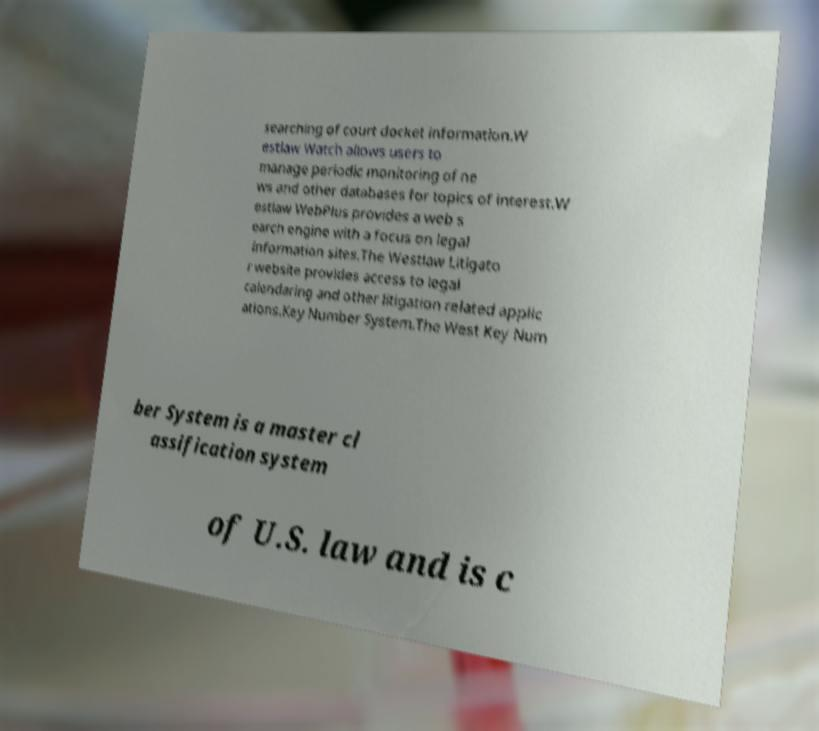There's text embedded in this image that I need extracted. Can you transcribe it verbatim? searching of court docket information.W estlaw Watch allows users to manage periodic monitoring of ne ws and other databases for topics of interest.W estlaw WebPlus provides a web s earch engine with a focus on legal information sites.The Westlaw Litigato r website provides access to legal calendaring and other litigation related applic ations.Key Number System.The West Key Num ber System is a master cl assification system of U.S. law and is c 